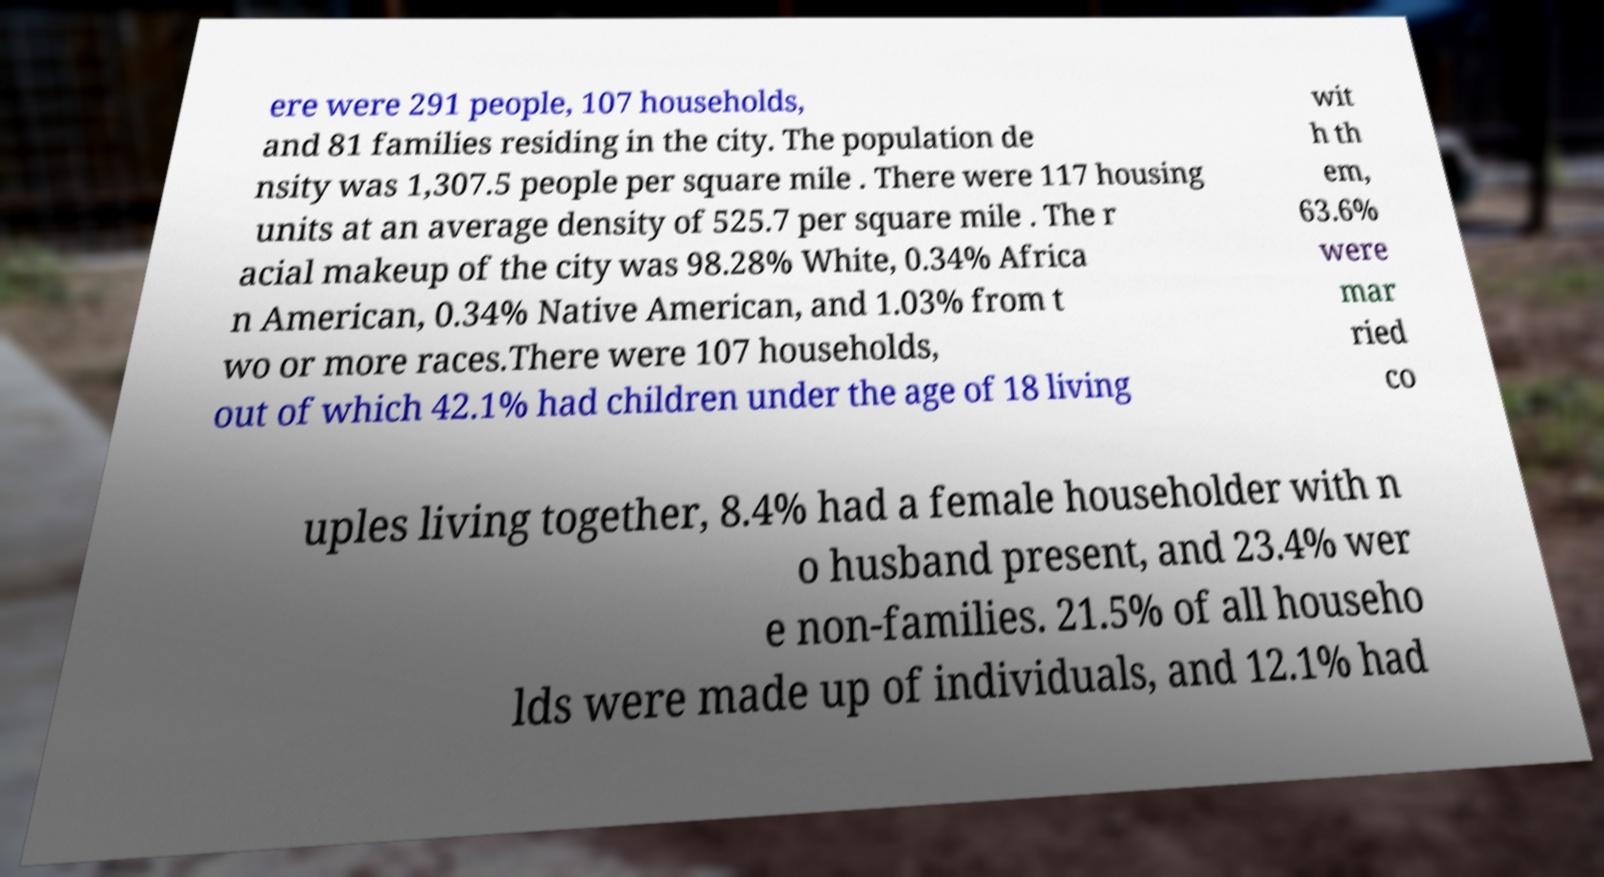I need the written content from this picture converted into text. Can you do that? ere were 291 people, 107 households, and 81 families residing in the city. The population de nsity was 1,307.5 people per square mile . There were 117 housing units at an average density of 525.7 per square mile . The r acial makeup of the city was 98.28% White, 0.34% Africa n American, 0.34% Native American, and 1.03% from t wo or more races.There were 107 households, out of which 42.1% had children under the age of 18 living wit h th em, 63.6% were mar ried co uples living together, 8.4% had a female householder with n o husband present, and 23.4% wer e non-families. 21.5% of all househo lds were made up of individuals, and 12.1% had 